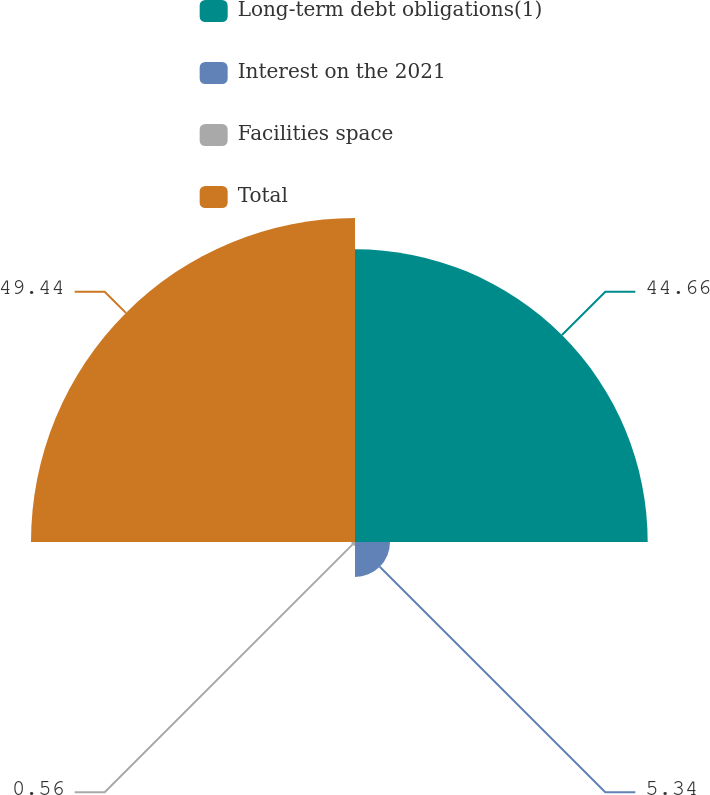<chart> <loc_0><loc_0><loc_500><loc_500><pie_chart><fcel>Long-term debt obligations(1)<fcel>Interest on the 2021<fcel>Facilities space<fcel>Total<nl><fcel>44.66%<fcel>5.34%<fcel>0.56%<fcel>49.44%<nl></chart> 